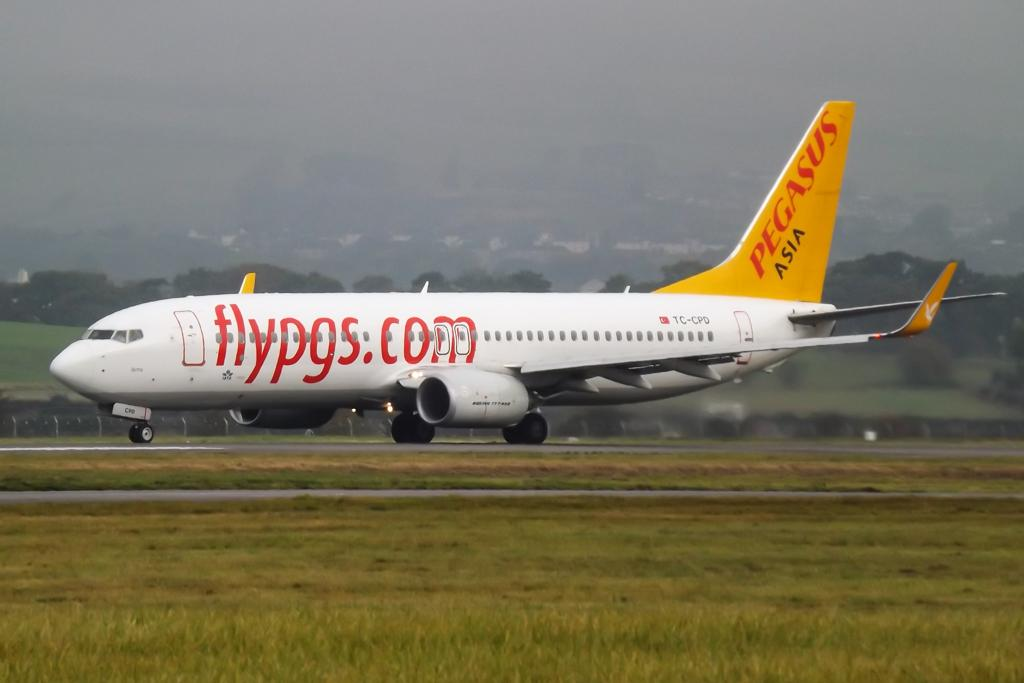What is the main subject of the image? The main subject of the image is an airplane on the ground. What can be seen in the middle of the image? There are many trees in the middle of the image. How is the ground depicted in the image? The ground is filled with grasses. Can you see any attractions or yaks in the image? There are no attractions or yaks present in the image. 